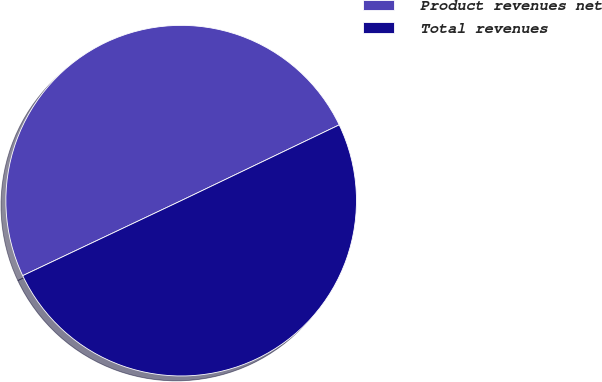Convert chart to OTSL. <chart><loc_0><loc_0><loc_500><loc_500><pie_chart><fcel>Product revenues net<fcel>Total revenues<nl><fcel>49.92%<fcel>50.08%<nl></chart> 